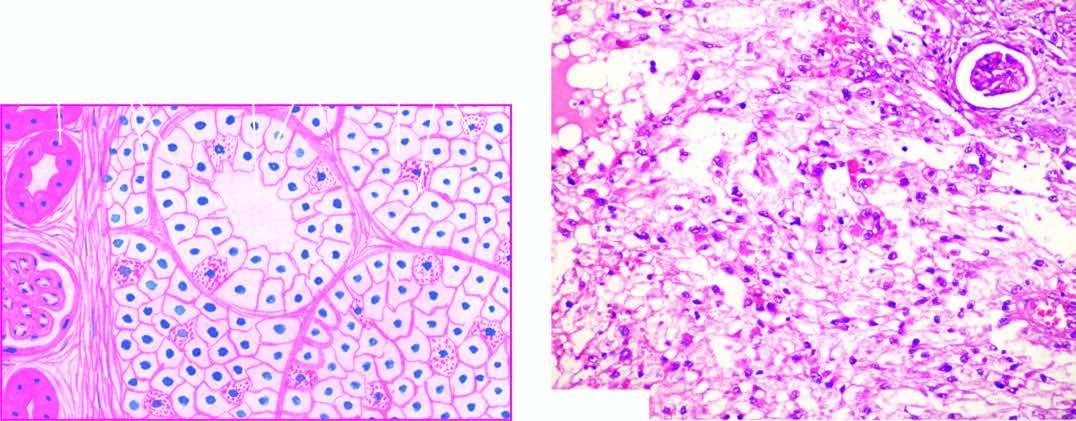where do clear cells predominate in?
Answer the question using a single word or phrase. Tumour 